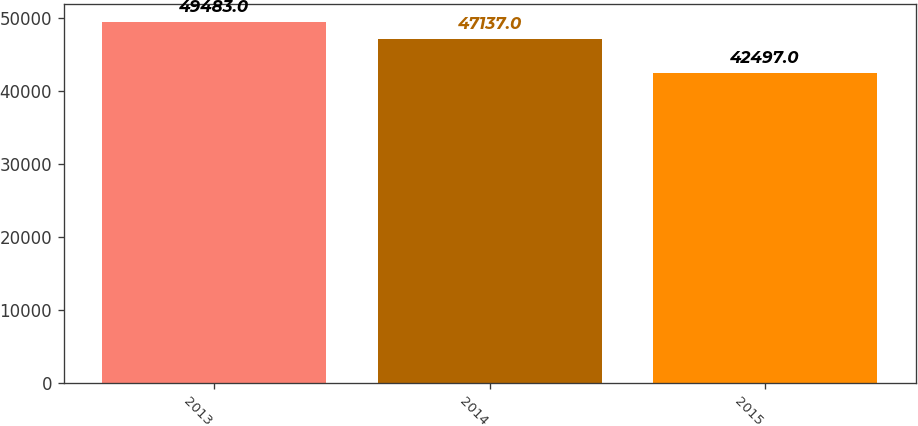<chart> <loc_0><loc_0><loc_500><loc_500><bar_chart><fcel>2013<fcel>2014<fcel>2015<nl><fcel>49483<fcel>47137<fcel>42497<nl></chart> 